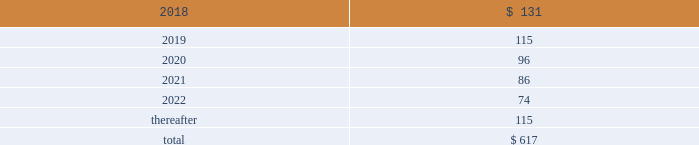13 .
Rentals and leases the company leases sales and administrative office facilities , distribution centers , research and manufacturing facilities , as well as vehicles and other equipment under operating leases .
Total rental expense under the company 2019s operating leases was $ 239 million in 2017 and $ 221 million in both 2016 and 2015 .
As of december 31 , 2017 , identifiable future minimum payments with non-cancelable terms in excess of one year were : ( millions ) .
The company enters into operating leases for vehicles whose non-cancelable terms are one year or less in duration with month-to-month renewal options .
These leases have been excluded from the table above .
The company estimates payments under such leases will approximate $ 62 million in 2018 .
These vehicle leases have guaranteed residual values that have historically been satisfied by the proceeds on the sale of the vehicles .
14 .
Research and development expenditures research expenditures that relate to the development of new products and processes , including significant improvements and refinements to existing products , are expensed as incurred .
Such costs were $ 201 million in 2017 , $ 189 million in 2016 and $ 191 million in 2015 .
The company did not participate in any material customer sponsored research during 2017 , 2016 or 2015 .
15 .
Commitments and contingencies the company is subject to various claims and contingencies related to , among other things , workers 2019 compensation , general liability ( including product liability ) , automobile claims , health care claims , environmental matters and lawsuits .
The company is also subject to various claims and contingencies related to income taxes , which are discussed in note 12 .
The company also has contractual obligations including lease commitments , which are discussed in note 13 .
The company records liabilities where a contingent loss is probable and can be reasonably estimated .
If the reasonable estimate of a probable loss is a range , the company records the most probable estimate of the loss or the minimum amount when no amount within the range is a better estimate than any other amount .
The company discloses a contingent liability even if the liability is not probable or the amount is not estimable , or both , if there is a reasonable possibility that a material loss may have been incurred .
Insurance globally , the company has insurance policies with varying deductibility levels for property and casualty losses .
The company is insured for losses in excess of these deductibles , subject to policy terms and conditions and has recorded both a liability and an offsetting receivable for amounts in excess of these deductibles .
The company is self-insured for health care claims for eligible participating employees , subject to certain deductibles and limitations .
The company determines its liabilities for claims on an actuarial basis .
Litigation and environmental matters the company and certain subsidiaries are party to various lawsuits , claims and environmental actions that have arisen in the ordinary course of business .
These include from time to time antitrust , commercial , patent infringement , product liability and wage hour lawsuits , as well as possible obligations to investigate and mitigate the effects on the environment of the disposal or release of certain chemical substances at various sites , such as superfund sites and other operating or closed facilities .
The company has established accruals for certain lawsuits , claims and environmental matters .
The company currently believes that there is not a reasonably possible risk of material loss in excess of the amounts accrued related to these legal matters .
Because litigation is inherently uncertain , and unfavorable rulings or developments could occur , there can be no certainty that the company may not ultimately incur charges in excess of recorded liabilities .
A future adverse ruling , settlement or unfavorable development could result in future charges that could have a material adverse effect on the company 2019s results of operations or cash flows in the period in which they are recorded .
The company currently believes that such future charges related to suits and legal claims , if any , would not have a material adverse effect on the company 2019s consolidated financial position .
Environmental matters the company is currently participating in environmental assessments and remediation at approximately 45 locations , the majority of which are in the u.s. , and environmental liabilities have been accrued reflecting management 2019s best estimate of future costs .
Potential insurance reimbursements are not anticipated in the company 2019s accruals for environmental liabilities. .
What were total r&e expenses in millions for 2017 , 2016 and in 2015? 
Computations: ((201 + 189) + 191)
Answer: 581.0. 